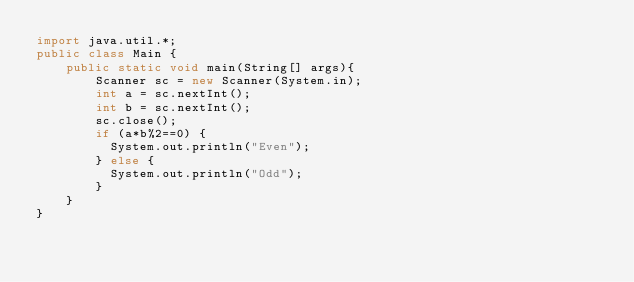Convert code to text. <code><loc_0><loc_0><loc_500><loc_500><_Java_>import java.util.*;
public class Main {
	public static void main(String[] args){
		Scanner sc = new Scanner(System.in);
		int a = sc.nextInt();
      	int b = sc.nextInt();
      	sc.close();
      	if (a*b%2==0) {
          System.out.println("Even");
        } else {
          System.out.println("Odd");
        }
	}
}</code> 